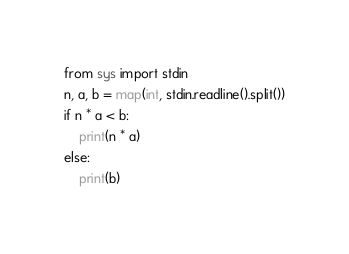Convert code to text. <code><loc_0><loc_0><loc_500><loc_500><_Python_>from sys import stdin
n, a, b = map(int, stdin.readline().split())
if n * a < b:
    print(n * a)
else:
    print(b)</code> 